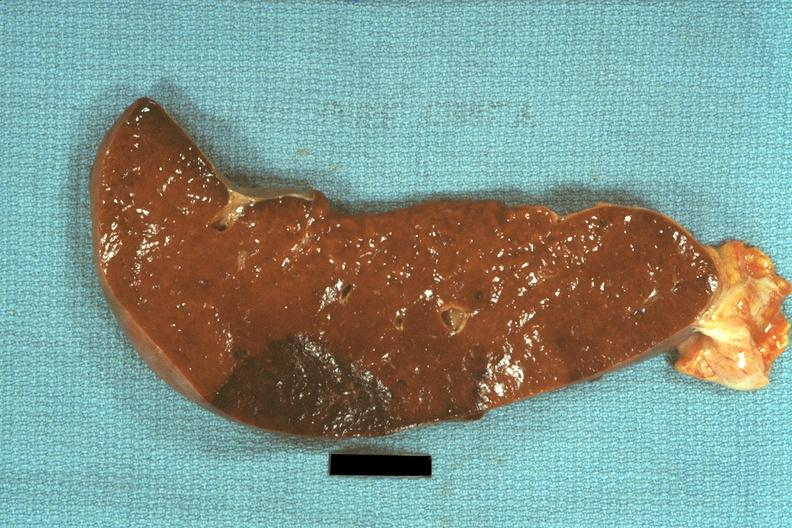s choanal atresia present?
Answer the question using a single word or phrase. No 